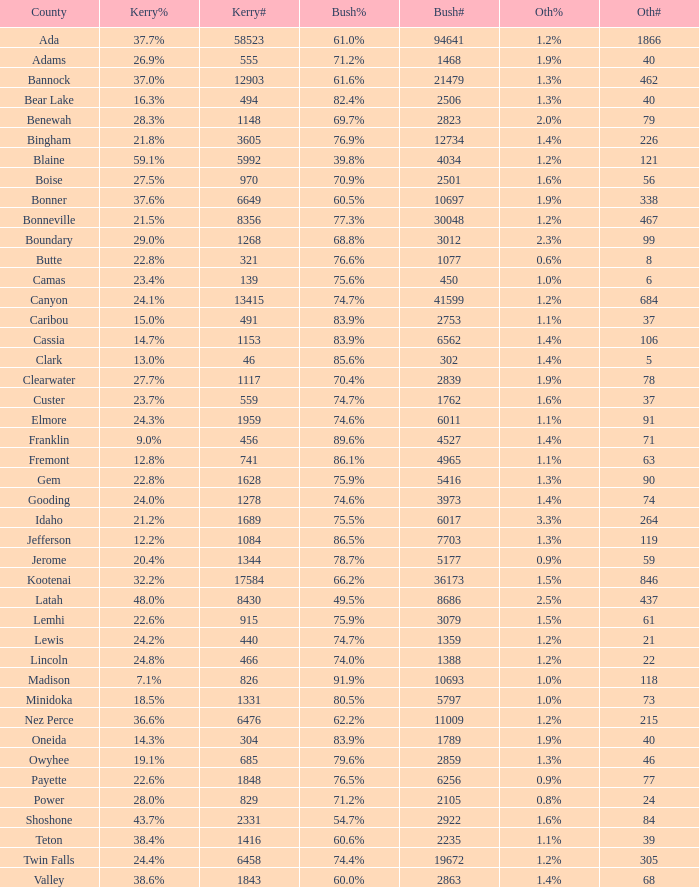What percentage of the votes in Oneida did Kerry win? 14.3%. 